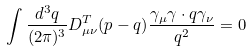Convert formula to latex. <formula><loc_0><loc_0><loc_500><loc_500>\int \frac { d ^ { 3 } q } { ( 2 \pi ) ^ { 3 } } D _ { \mu \nu } ^ { T } ( p - q ) \frac { \gamma _ { \mu } \gamma \cdot q \gamma _ { \nu } } { q ^ { 2 } } = 0</formula> 